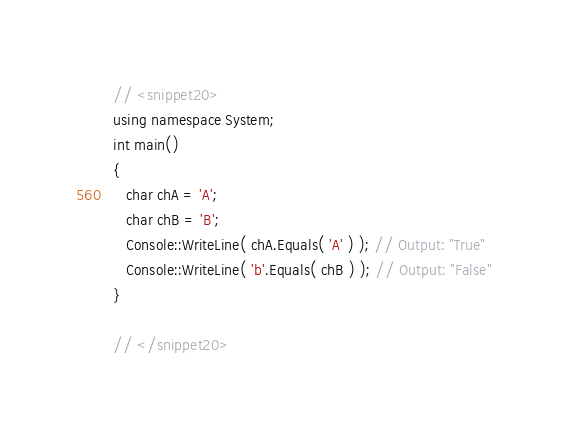Convert code to text. <code><loc_0><loc_0><loc_500><loc_500><_C++_>
// <snippet20>
using namespace System;
int main()
{
   char chA = 'A';
   char chB = 'B';
   Console::WriteLine( chA.Equals( 'A' ) ); // Output: "True"
   Console::WriteLine( 'b'.Equals( chB ) ); // Output: "False"
}

// </snippet20>
</code> 